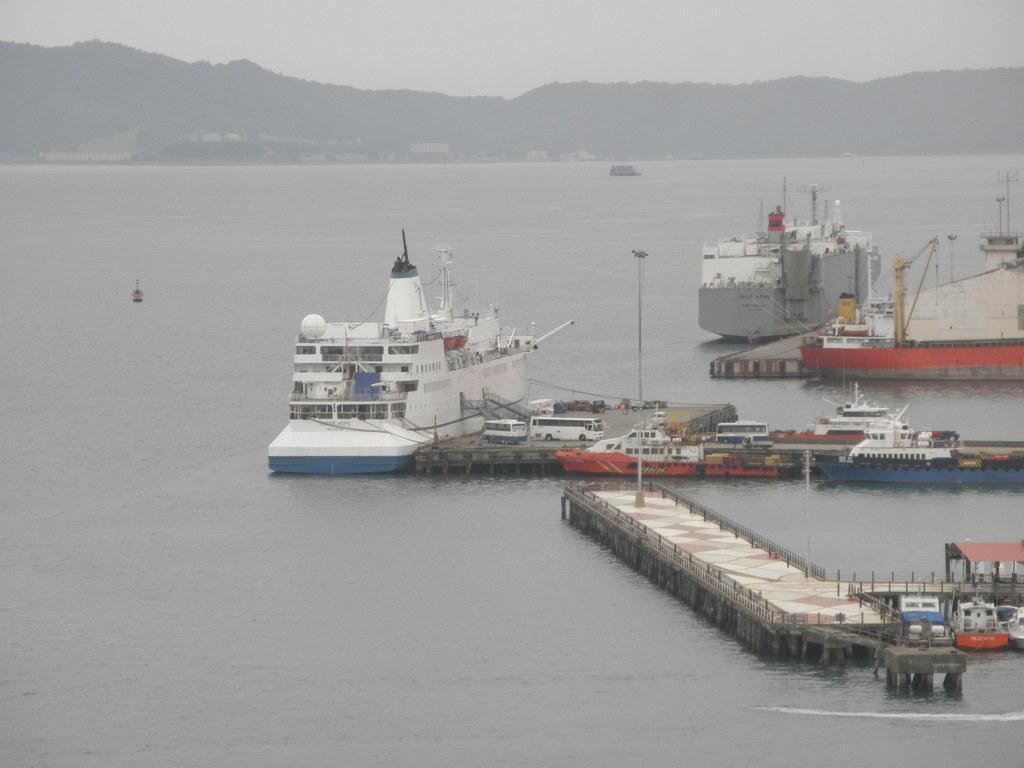Please provide a concise description of this image. The picture is taken near a shipping harbour. In the foreground of the picture there are ships and docks. In the foreground there is water. In the center of the picture there are hills covered with trees. Sky is cloudy. 